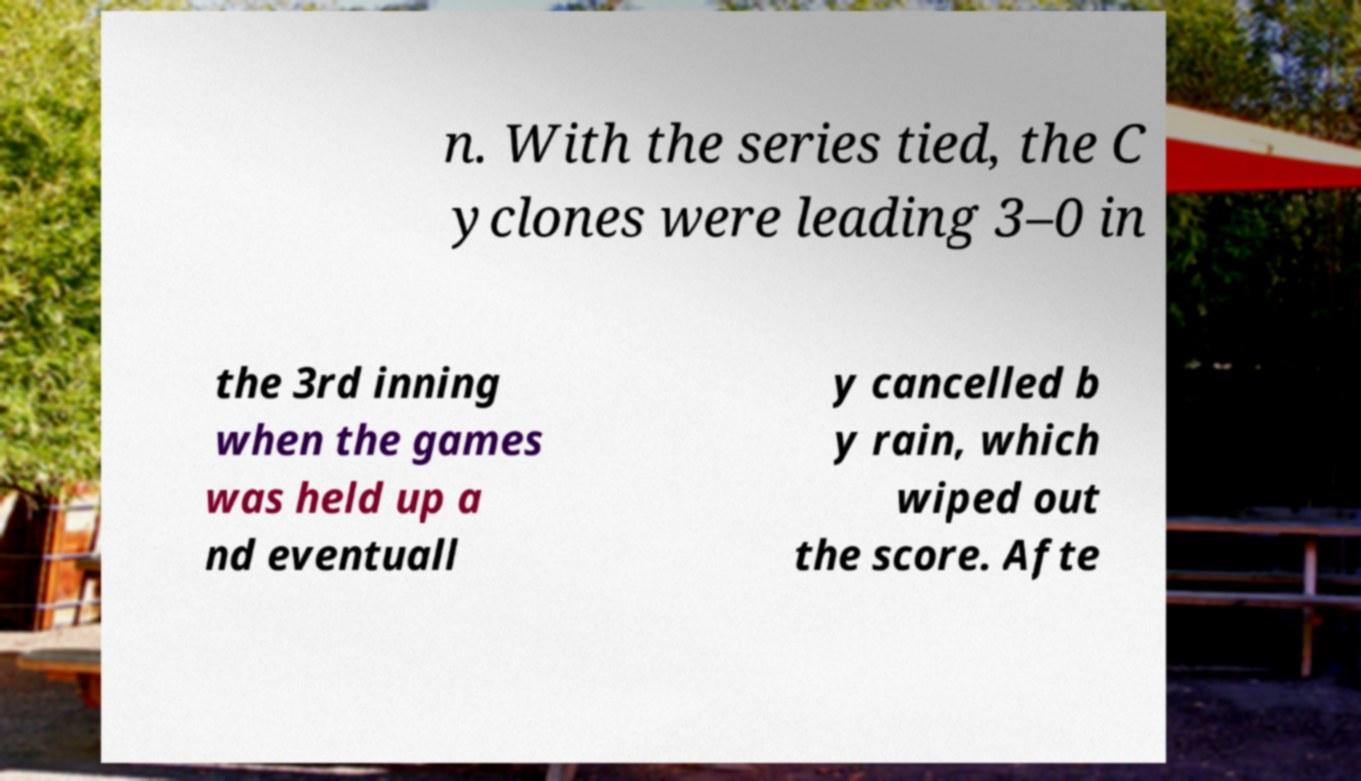Please read and relay the text visible in this image. What does it say? n. With the series tied, the C yclones were leading 3–0 in the 3rd inning when the games was held up a nd eventuall y cancelled b y rain, which wiped out the score. Afte 